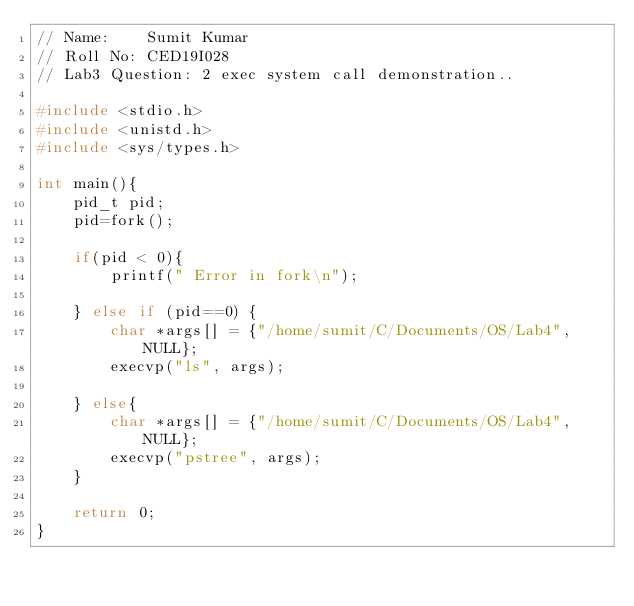Convert code to text. <code><loc_0><loc_0><loc_500><loc_500><_C_>// Name:    Sumit Kumar
// Roll No: CED19I028
// Lab3 Question: 2 exec system call demonstration..

#include <stdio.h>
#include <unistd.h>
#include <sys/types.h>

int main(){
    pid_t pid;
    pid=fork();
    
    if(pid < 0){
        printf(" Error in fork\n");
    
    } else if (pid==0) {
        char *args[] = {"/home/sumit/C/Documents/OS/Lab4", NULL};
        execvp("ls", args);
    
    } else{
        char *args[] = {"/home/sumit/C/Documents/OS/Lab4", NULL};
        execvp("pstree", args);
    }

    return 0;
}</code> 